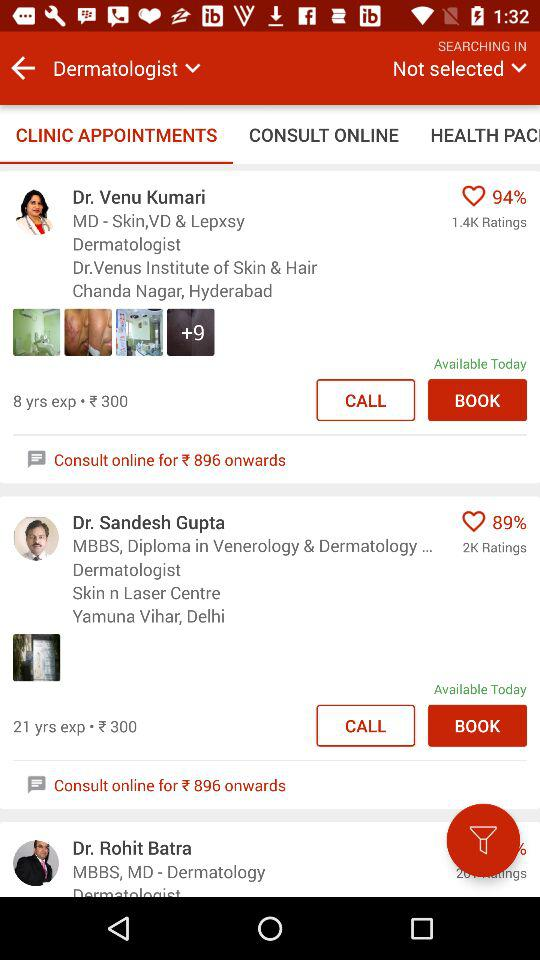How much is the fee of Dr. Venu Kumari? The fee of Dr. Venu Kumari is ₹300. 